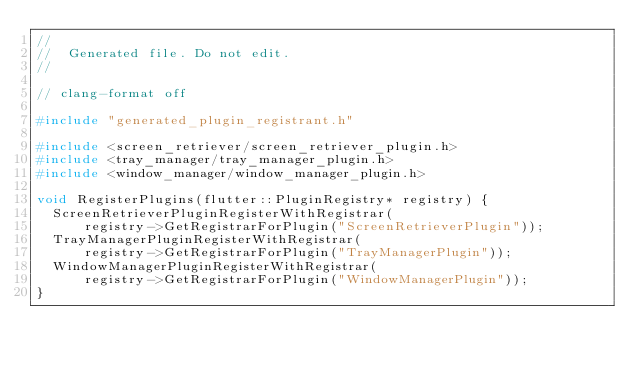Convert code to text. <code><loc_0><loc_0><loc_500><loc_500><_C++_>//
//  Generated file. Do not edit.
//

// clang-format off

#include "generated_plugin_registrant.h"

#include <screen_retriever/screen_retriever_plugin.h>
#include <tray_manager/tray_manager_plugin.h>
#include <window_manager/window_manager_plugin.h>

void RegisterPlugins(flutter::PluginRegistry* registry) {
  ScreenRetrieverPluginRegisterWithRegistrar(
      registry->GetRegistrarForPlugin("ScreenRetrieverPlugin"));
  TrayManagerPluginRegisterWithRegistrar(
      registry->GetRegistrarForPlugin("TrayManagerPlugin"));
  WindowManagerPluginRegisterWithRegistrar(
      registry->GetRegistrarForPlugin("WindowManagerPlugin"));
}
</code> 